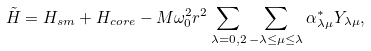Convert formula to latex. <formula><loc_0><loc_0><loc_500><loc_500>\tilde { H } = H _ { s m } + H _ { c o r e } - M \omega _ { 0 } ^ { 2 } r ^ { 2 } \sum _ { \lambda = 0 , 2 } \sum _ { - \lambda \leq \mu \leq \lambda } \alpha _ { \lambda \mu } ^ { * } Y _ { \lambda \mu } ,</formula> 